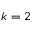<formula> <loc_0><loc_0><loc_500><loc_500>k = 2</formula> 